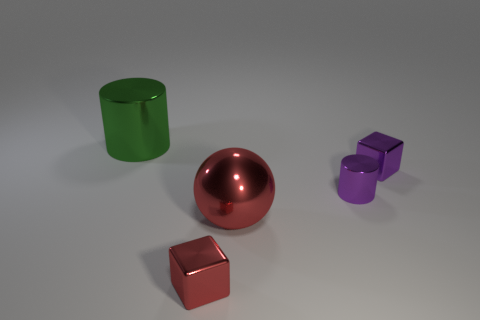What size is the purple metallic cylinder?
Keep it short and to the point. Small. How big is the red ball to the right of the green metallic cylinder?
Keep it short and to the point. Large. There is a object that is both on the left side of the purple cylinder and behind the purple cylinder; what is its shape?
Offer a terse response. Cylinder. What number of other objects are there of the same shape as the large green metal thing?
Make the answer very short. 1. What color is the other metal block that is the same size as the red cube?
Make the answer very short. Purple. How many things are large green metal objects or purple shiny things?
Provide a short and direct response. 3. There is a green shiny object; are there any cylinders to the right of it?
Make the answer very short. Yes. Is there a red cube made of the same material as the purple cylinder?
Make the answer very short. Yes. There is a metallic block that is the same color as the big metallic sphere; what is its size?
Provide a short and direct response. Small. What number of balls are green metal things or tiny purple things?
Give a very brief answer. 0. 